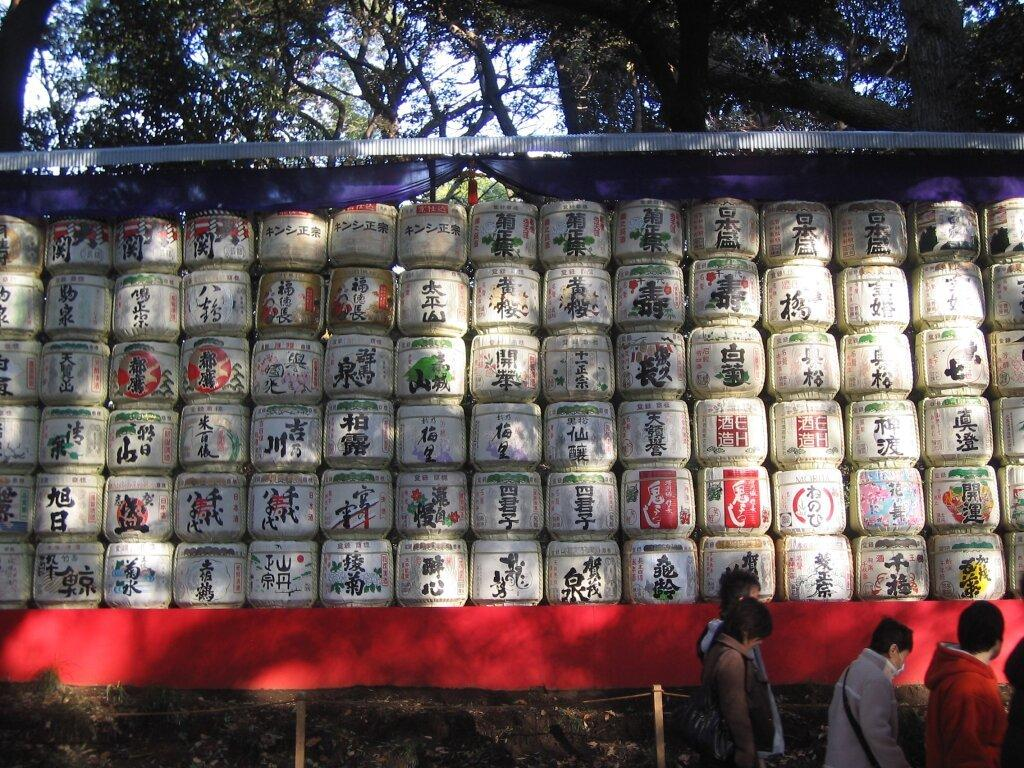What type of containers are visible in the image? There are plastic containers in the image. How are the containers arranged? The containers are arranged in the image. What can be seen on the containers? There is writing on the containers. What can be seen in the background of the image? There are trees in the background of the image. Where are the people located in the image? People are present at the right bottom of the image. How many geese are swimming in the tub in the image? There is no tub or geese present in the image. 